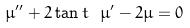Convert formula to latex. <formula><loc_0><loc_0><loc_500><loc_500>\mu ^ { \prime \prime } + 2 \tan t \ \mu ^ { \prime } - 2 \mu = 0</formula> 